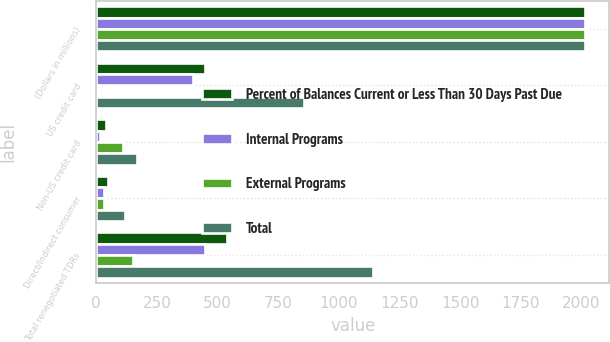<chart> <loc_0><loc_0><loc_500><loc_500><stacked_bar_chart><ecel><fcel>(Dollars in millions)<fcel>US credit card<fcel>Non-US credit card<fcel>Direct/Indirect consumer<fcel>Total renegotiated TDRs<nl><fcel>Percent of Balances Current or Less Than 30 Days Past Due<fcel>2014<fcel>450<fcel>41<fcel>50<fcel>541<nl><fcel>Internal Programs<fcel>2014<fcel>397<fcel>16<fcel>34<fcel>447<nl><fcel>External Programs<fcel>2014<fcel>9<fcel>111<fcel>33<fcel>153<nl><fcel>Total<fcel>2014<fcel>856<fcel>168<fcel>117<fcel>1141<nl></chart> 